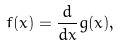<formula> <loc_0><loc_0><loc_500><loc_500>f ( x ) = \frac { d } { d x } g ( x ) ,</formula> 